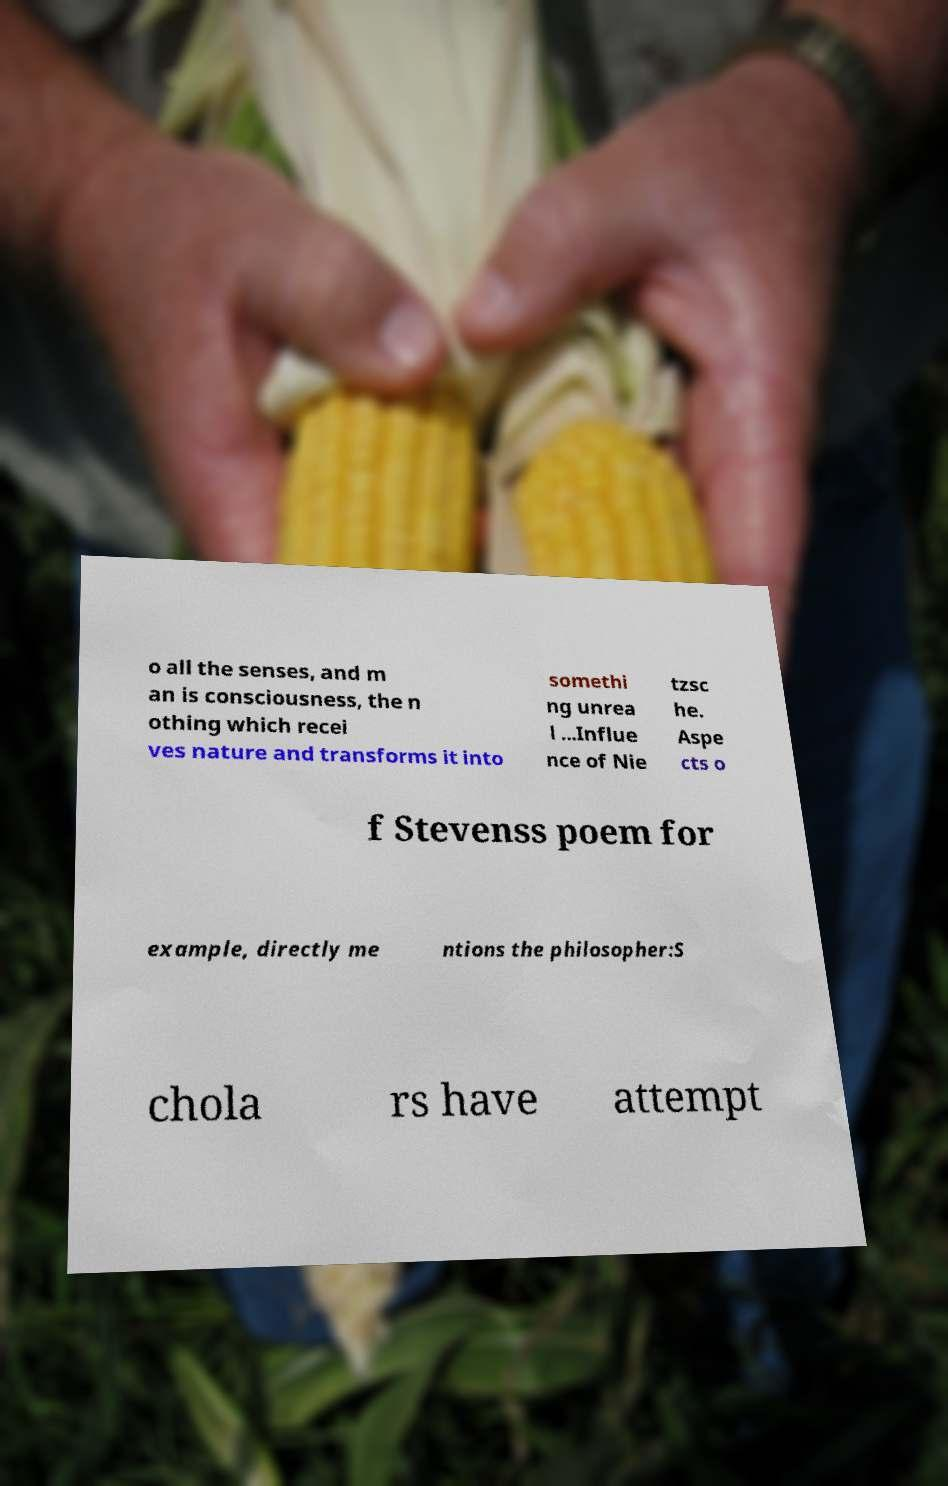Can you accurately transcribe the text from the provided image for me? o all the senses, and m an is consciousness, the n othing which recei ves nature and transforms it into somethi ng unrea l ...Influe nce of Nie tzsc he. Aspe cts o f Stevenss poem for example, directly me ntions the philosopher:S chola rs have attempt 